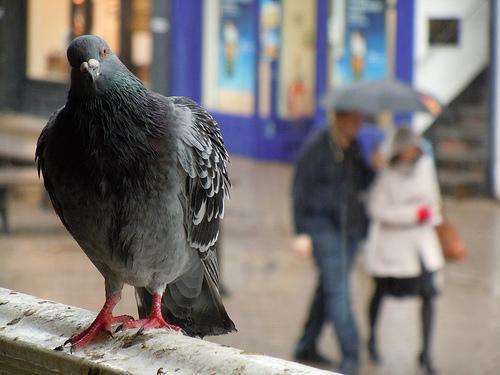How many birds are there?
Give a very brief answer. 1. 